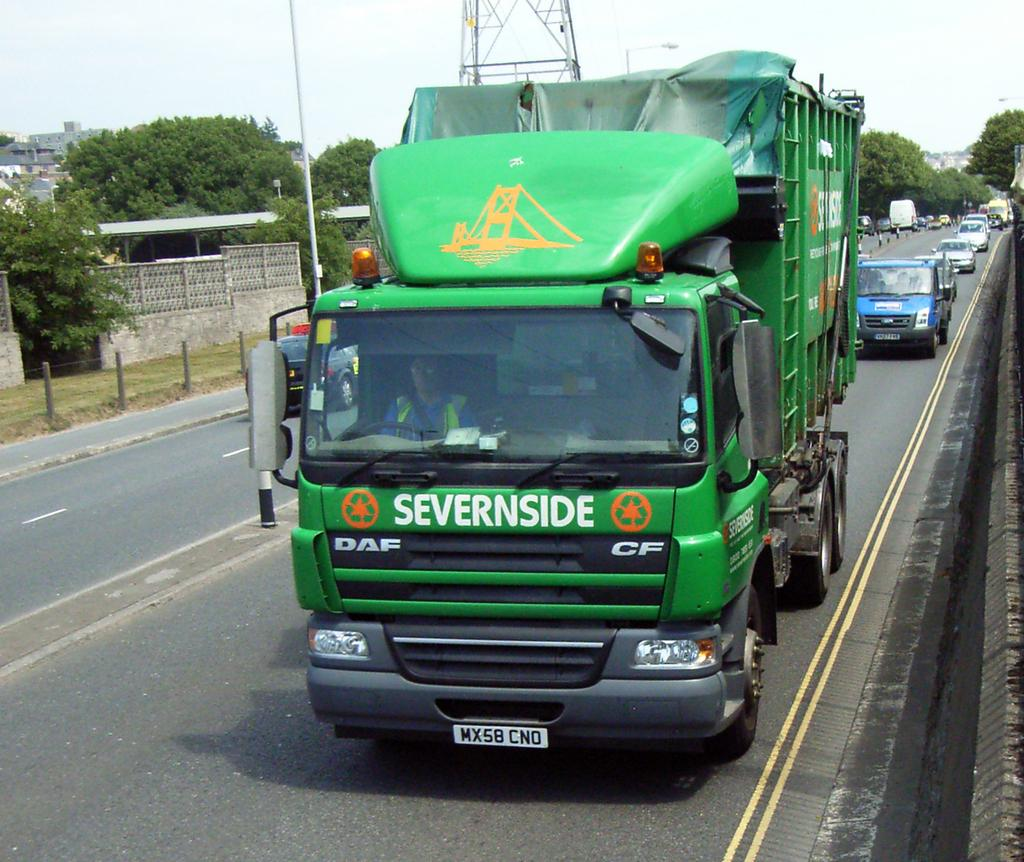What type: What types of vehicles can be seen on the road in the image? There are vehicles on the road in the image. What is the barrier separating the road from the grassy area in the image? There is a fence in the image. What type of vegetation is present in the image? There is grass and trees in the image. What type of structures can be seen in the image? There are buildings, a pole, and a tower in the image. What is visible in the background of the image? The sky is visible in the background of the image. What degree of difficulty does the action in the image present? There is no action or difficulty level present in the image; it is a static scene. 